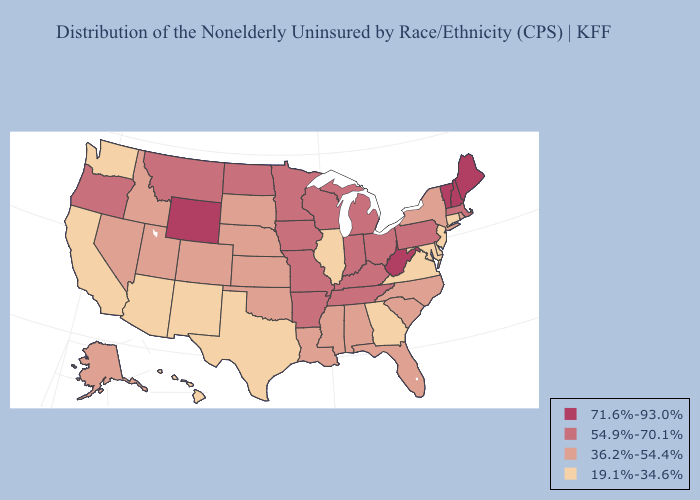Which states have the lowest value in the USA?
Answer briefly. Arizona, California, Connecticut, Delaware, Georgia, Hawaii, Illinois, Maryland, New Jersey, New Mexico, Texas, Virginia, Washington. What is the value of California?
Be succinct. 19.1%-34.6%. Does Colorado have the same value as West Virginia?
Be succinct. No. What is the lowest value in states that border Alabama?
Give a very brief answer. 19.1%-34.6%. What is the lowest value in the South?
Give a very brief answer. 19.1%-34.6%. Does the map have missing data?
Answer briefly. No. Does Alaska have the highest value in the West?
Give a very brief answer. No. What is the value of Maryland?
Keep it brief. 19.1%-34.6%. What is the value of Virginia?
Keep it brief. 19.1%-34.6%. Name the states that have a value in the range 54.9%-70.1%?
Give a very brief answer. Arkansas, Indiana, Iowa, Kentucky, Massachusetts, Michigan, Minnesota, Missouri, Montana, North Dakota, Ohio, Oregon, Pennsylvania, Tennessee, Wisconsin. What is the highest value in states that border North Dakota?
Write a very short answer. 54.9%-70.1%. Does Pennsylvania have the lowest value in the Northeast?
Short answer required. No. What is the highest value in states that border Wyoming?
Be succinct. 54.9%-70.1%. Does the first symbol in the legend represent the smallest category?
Answer briefly. No. Does Georgia have the lowest value in the South?
Give a very brief answer. Yes. 